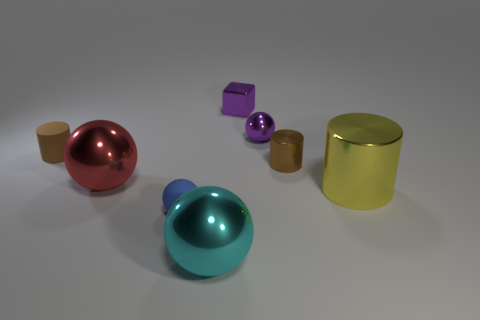Subtract all purple balls. How many balls are left? 3 Subtract all big red spheres. How many spheres are left? 3 Subtract 2 spheres. How many spheres are left? 2 Add 1 yellow cylinders. How many objects exist? 9 Subtract all cylinders. How many objects are left? 5 Subtract all brown spheres. Subtract all blue blocks. How many spheres are left? 4 Add 2 big cubes. How many big cubes exist? 2 Subtract 0 gray cylinders. How many objects are left? 8 Subtract all gray matte cylinders. Subtract all tiny purple balls. How many objects are left? 7 Add 1 big yellow cylinders. How many big yellow cylinders are left? 2 